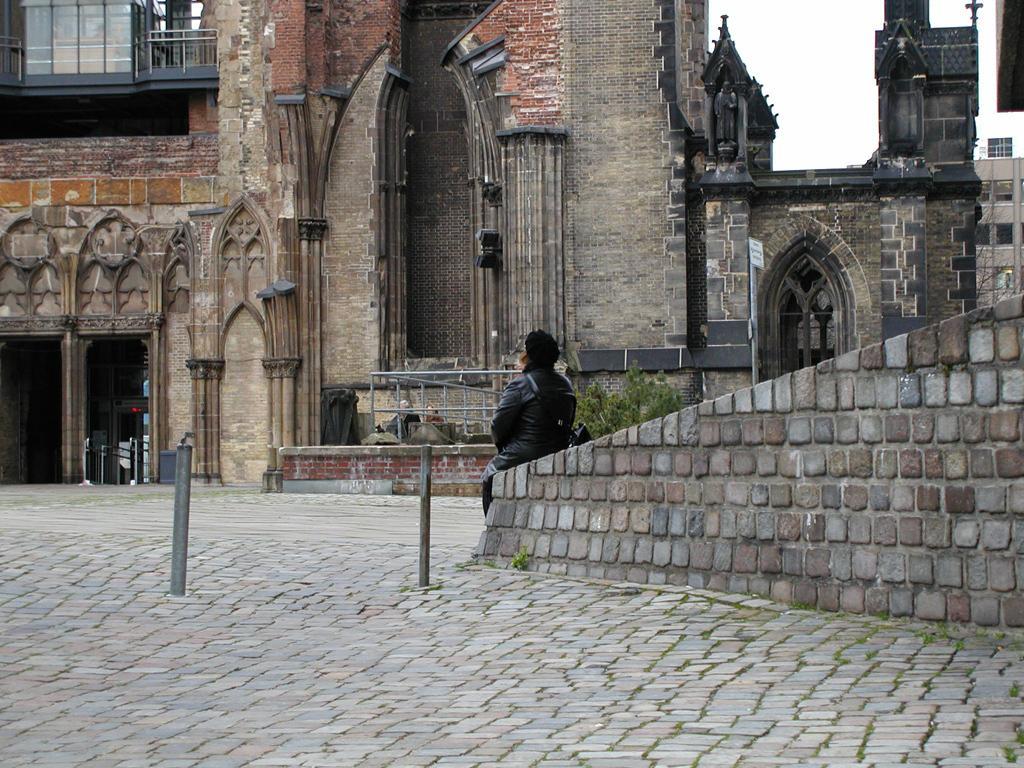Describe this image in one or two sentences. There is a person sitting in the foreground area of the image, it seems like bamboos on the left side. There is a building, on which there are arches and windows, pole and sky in the background area. 